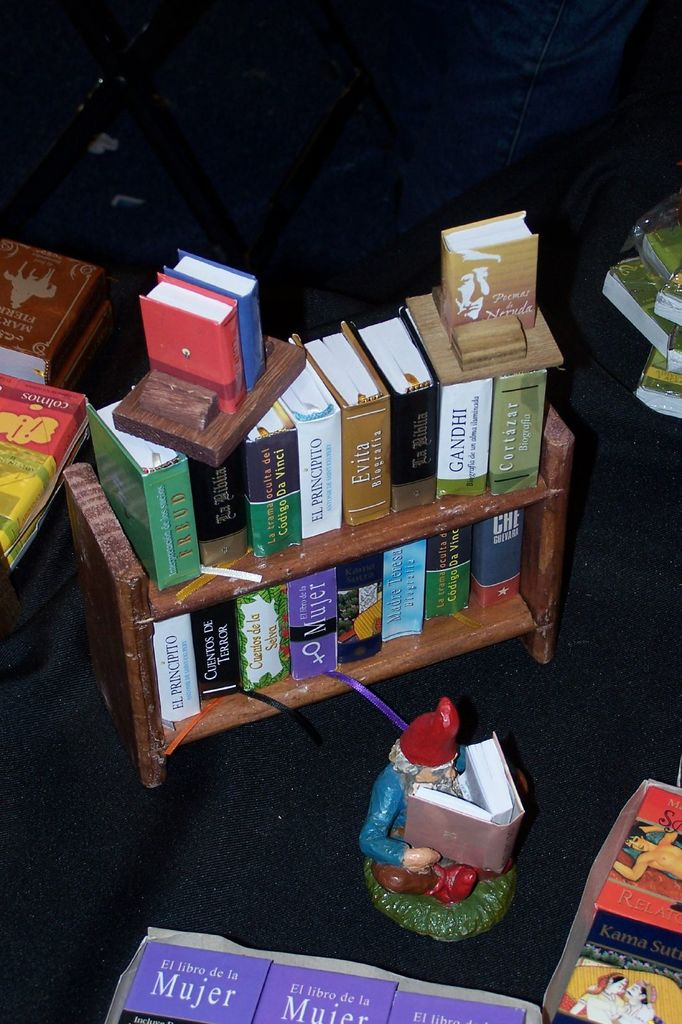Can you describe the theme or main idea behind this miniature book display? This miniature book display creatively represents a mythical or magical library scene, possibly intended to evoke a sense of wonder and curiosity about reading and literature. The presence of the gnome figure adds a playful, fairy-tale element, emphasizing the joy and escape books can provide. 